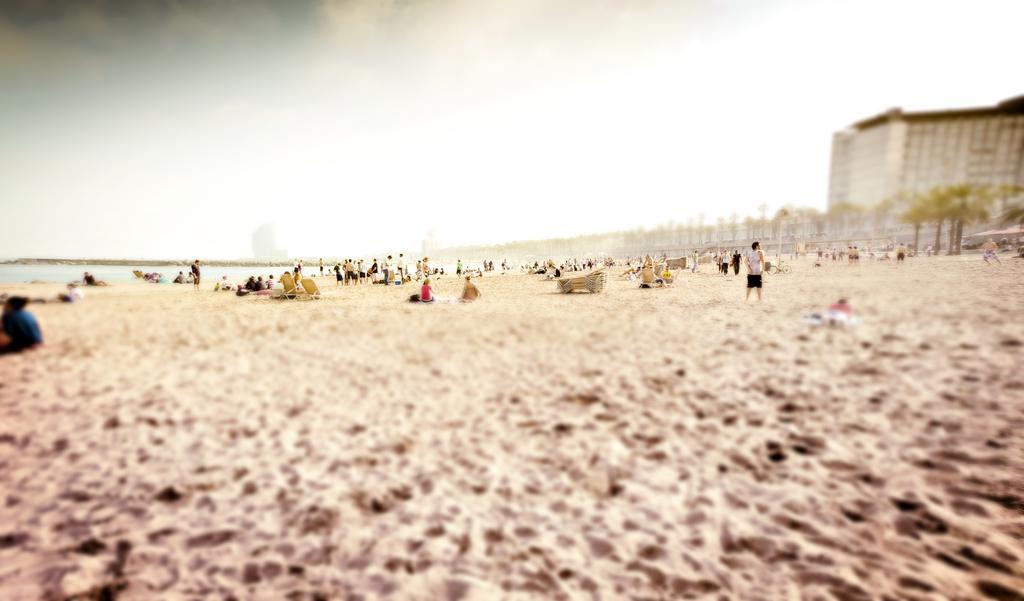Describe this image in one or two sentences. In this image I can see a group of people around. Few people are sitting on chairs. Back I can see few trees,water,buildings and sand. The sky is in white color. The image is blurred. 